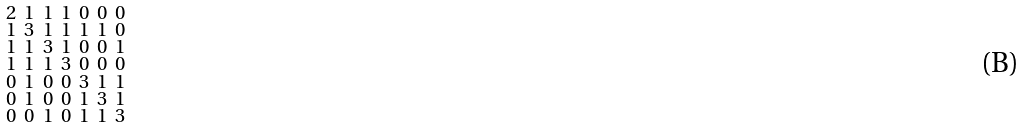<formula> <loc_0><loc_0><loc_500><loc_500>\begin{smallmatrix} 2 & 1 & 1 & 1 & 0 & 0 & 0 \\ 1 & 3 & 1 & 1 & 1 & 1 & 0 \\ 1 & 1 & 3 & 1 & 0 & 0 & 1 \\ 1 & 1 & 1 & 3 & 0 & 0 & 0 \\ 0 & 1 & 0 & 0 & 3 & 1 & 1 \\ 0 & 1 & 0 & 0 & 1 & 3 & 1 \\ 0 & 0 & 1 & 0 & 1 & 1 & 3 \end{smallmatrix}</formula> 